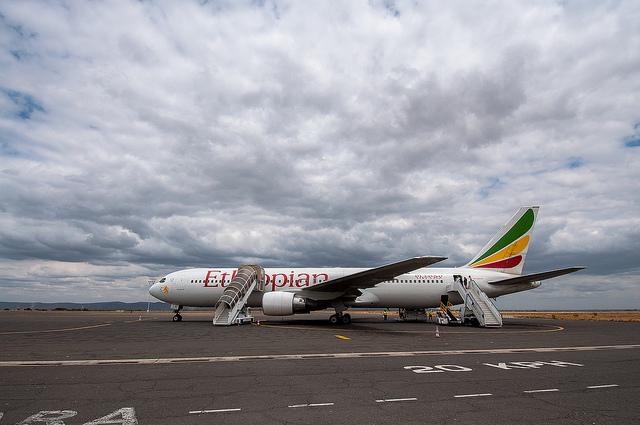Are the stairs put up?
Keep it brief. No. Are the passengers on board?
Quick response, please. Yes. Is it cloudy?
Be succinct. Yes. What does it say on the side of the plane?
Answer briefly. Ethiopian. How many planes are here?
Keep it brief. 1. 